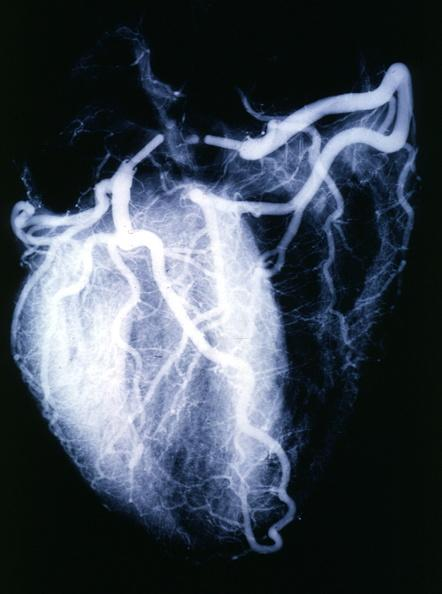what is present?
Answer the question using a single word or phrase. Cardiovascular 